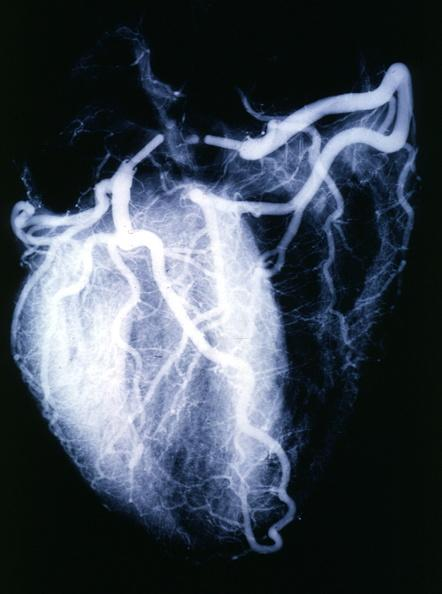what is present?
Answer the question using a single word or phrase. Cardiovascular 